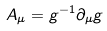<formula> <loc_0><loc_0><loc_500><loc_500>A _ { \mu } = g ^ { - 1 } \partial _ { \mu } g \,</formula> 